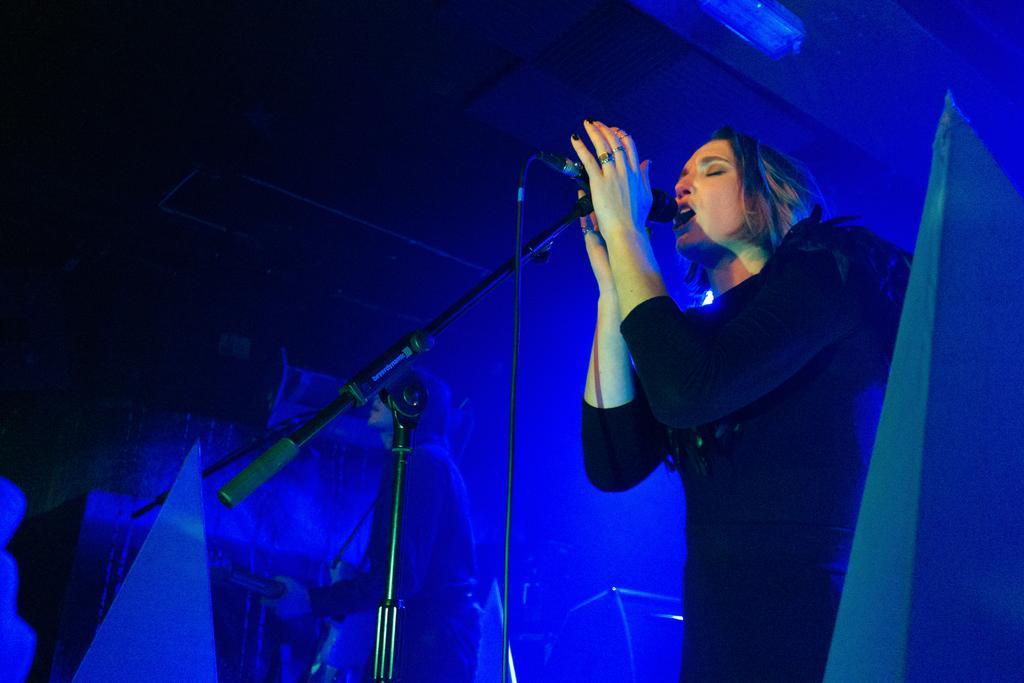Please provide a concise description of this image. In this picture there is a woman wearing black dress is standing and singing in front of a mic and there is another person standing and playing guitar beside her and the background is in blue color. 